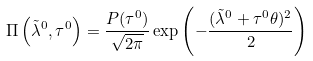<formula> <loc_0><loc_0><loc_500><loc_500>\Pi \left ( \tilde { \lambda } ^ { 0 } , \tau ^ { 0 } \right ) = \frac { P ( \tau ^ { 0 } ) } { \sqrt { 2 \pi } } \exp \left ( - \frac { ( \tilde { \lambda } ^ { 0 } + \tau ^ { 0 } \theta ) ^ { 2 } } { 2 } \right )</formula> 